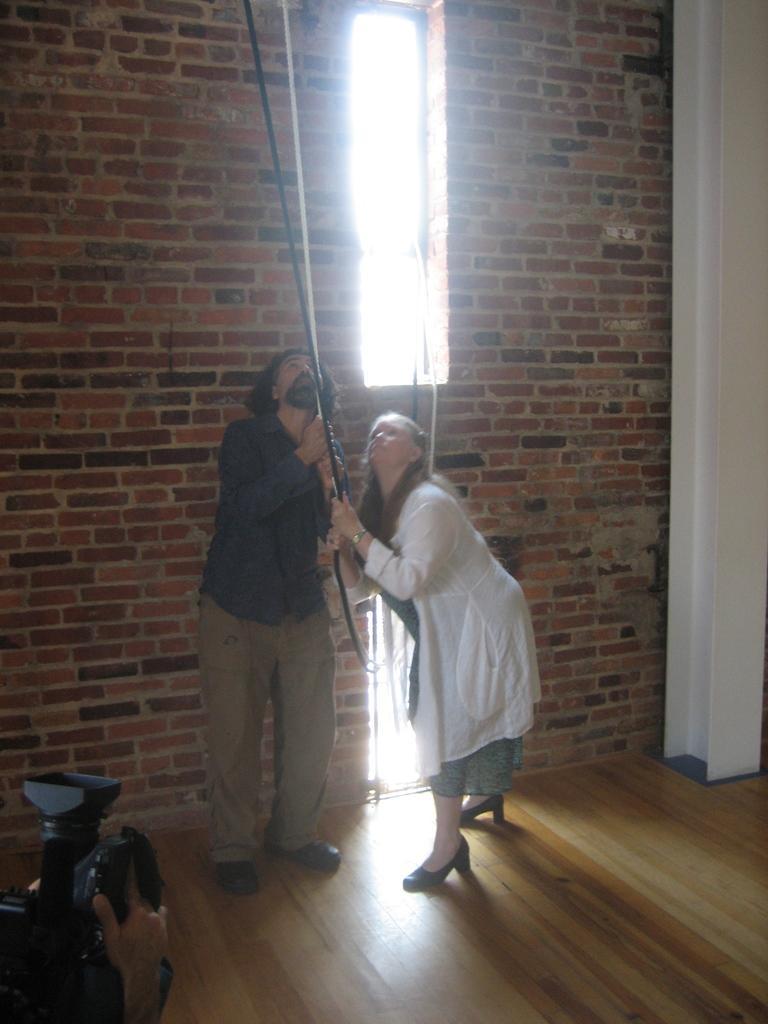Describe this image in one or two sentences. In the center of the image, we can see a man and a lady holding ropes and in the background, there is a wall and at the bottom, there is floor and there is a person holding a camera. 